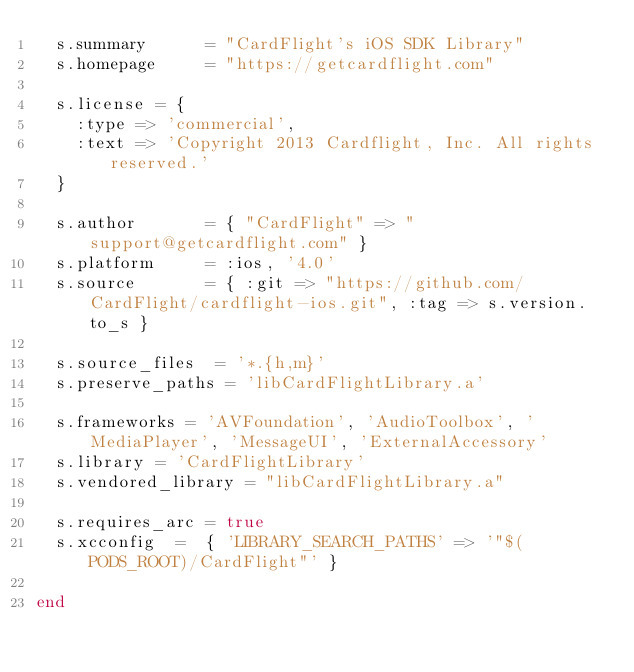<code> <loc_0><loc_0><loc_500><loc_500><_Ruby_>  s.summary      = "CardFlight's iOS SDK Library"
  s.homepage     = "https://getcardflight.com"

  s.license = {
    :type => 'commercial',
    :text => 'Copyright 2013 Cardflight, Inc. All rights reserved.'
  }

  s.author       = { "CardFlight" => "support@getcardflight.com" }
  s.platform     = :ios, '4.0'
  s.source       = { :git => "https://github.com/CardFlight/cardflight-ios.git", :tag => s.version.to_s }

  s.source_files  = '*.{h,m}'
  s.preserve_paths = 'libCardFlightLibrary.a'

  s.frameworks = 'AVFoundation', 'AudioToolbox', 'MediaPlayer', 'MessageUI', 'ExternalAccessory'
  s.library = 'CardFlightLibrary'
  s.vendored_library = "libCardFlightLibrary.a"

  s.requires_arc = true
  s.xcconfig  =  { 'LIBRARY_SEARCH_PATHS' => '"$(PODS_ROOT)/CardFlight"' }

end
</code> 